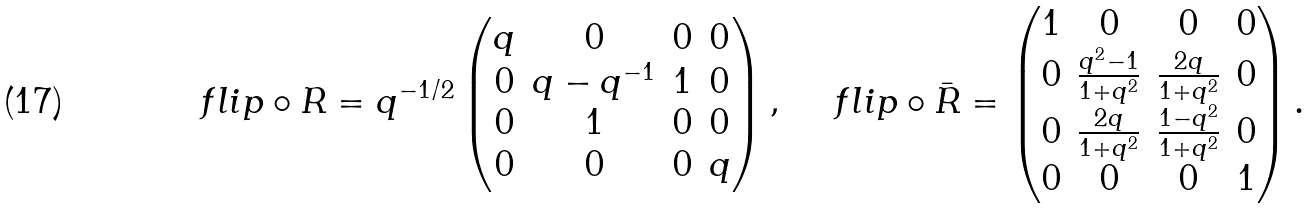<formula> <loc_0><loc_0><loc_500><loc_500>\ f l i p \circ R = q ^ { - 1 / 2 } \begin{pmatrix} q & 0 & 0 & 0 \\ 0 & q - q ^ { - 1 } & 1 & 0 \\ 0 & 1 & 0 & 0 \\ 0 & 0 & 0 & q \end{pmatrix} , \quad \ f l i p \circ \bar { R } = \begin{pmatrix} 1 & 0 & 0 & 0 \\ 0 & \frac { q ^ { 2 } - 1 } { 1 + q ^ { 2 } } & \frac { 2 q } { 1 + q ^ { 2 } } & 0 \\ 0 & \frac { 2 q } { 1 + q ^ { 2 } } & \frac { 1 - q ^ { 2 } } { 1 + q ^ { 2 } } & 0 \\ 0 & 0 & 0 & 1 \end{pmatrix} .</formula> 